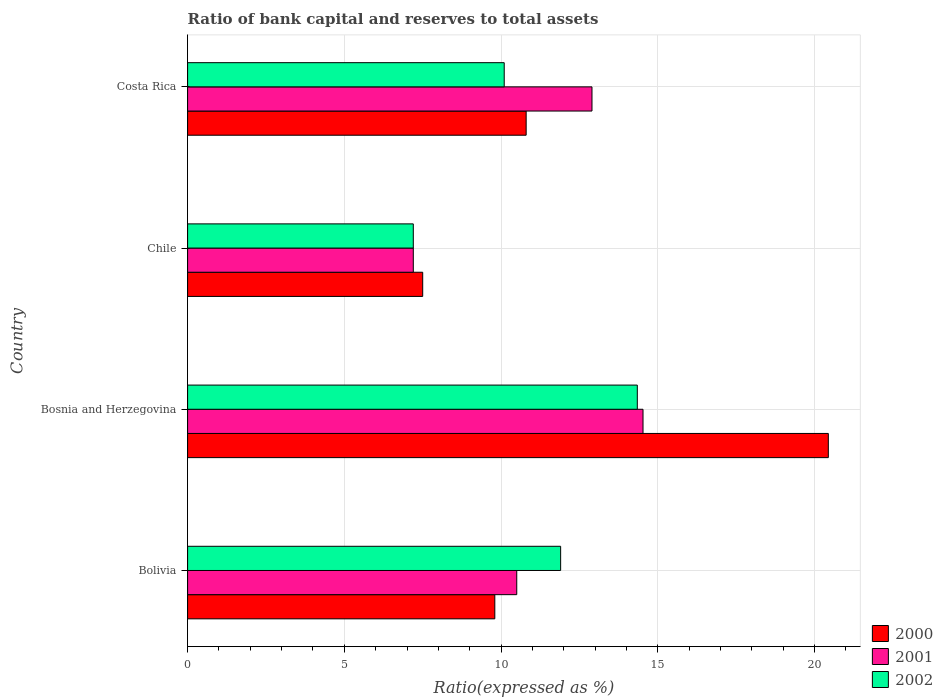How many groups of bars are there?
Offer a very short reply. 4. Are the number of bars on each tick of the Y-axis equal?
Your answer should be very brief. Yes. What is the label of the 2nd group of bars from the top?
Your response must be concise. Chile. What is the ratio of bank capital and reserves to total assets in 2001 in Chile?
Offer a very short reply. 7.2. Across all countries, what is the maximum ratio of bank capital and reserves to total assets in 2002?
Your answer should be compact. 14.35. In which country was the ratio of bank capital and reserves to total assets in 2001 maximum?
Provide a succinct answer. Bosnia and Herzegovina. In which country was the ratio of bank capital and reserves to total assets in 2002 minimum?
Provide a short and direct response. Chile. What is the total ratio of bank capital and reserves to total assets in 2000 in the graph?
Keep it short and to the point. 48.54. What is the difference between the ratio of bank capital and reserves to total assets in 2002 in Bolivia and that in Costa Rica?
Give a very brief answer. 1.8. What is the difference between the ratio of bank capital and reserves to total assets in 2000 in Bolivia and the ratio of bank capital and reserves to total assets in 2002 in Bosnia and Herzegovina?
Make the answer very short. -4.55. What is the average ratio of bank capital and reserves to total assets in 2001 per country?
Give a very brief answer. 11.28. What is the difference between the ratio of bank capital and reserves to total assets in 2001 and ratio of bank capital and reserves to total assets in 2002 in Costa Rica?
Offer a very short reply. 2.8. In how many countries, is the ratio of bank capital and reserves to total assets in 2000 greater than 15 %?
Offer a very short reply. 1. What is the ratio of the ratio of bank capital and reserves to total assets in 2002 in Chile to that in Costa Rica?
Ensure brevity in your answer.  0.71. Is the difference between the ratio of bank capital and reserves to total assets in 2001 in Bolivia and Bosnia and Herzegovina greater than the difference between the ratio of bank capital and reserves to total assets in 2002 in Bolivia and Bosnia and Herzegovina?
Ensure brevity in your answer.  No. What is the difference between the highest and the second highest ratio of bank capital and reserves to total assets in 2000?
Offer a terse response. 9.64. What is the difference between the highest and the lowest ratio of bank capital and reserves to total assets in 2001?
Provide a succinct answer. 7.33. In how many countries, is the ratio of bank capital and reserves to total assets in 2000 greater than the average ratio of bank capital and reserves to total assets in 2000 taken over all countries?
Offer a terse response. 1. Is the sum of the ratio of bank capital and reserves to total assets in 2000 in Chile and Costa Rica greater than the maximum ratio of bank capital and reserves to total assets in 2002 across all countries?
Your answer should be compact. Yes. What does the 3rd bar from the bottom in Costa Rica represents?
Give a very brief answer. 2002. What is the difference between two consecutive major ticks on the X-axis?
Your answer should be very brief. 5. Are the values on the major ticks of X-axis written in scientific E-notation?
Give a very brief answer. No. Does the graph contain any zero values?
Keep it short and to the point. No. How are the legend labels stacked?
Your response must be concise. Vertical. What is the title of the graph?
Make the answer very short. Ratio of bank capital and reserves to total assets. Does "1988" appear as one of the legend labels in the graph?
Your response must be concise. No. What is the label or title of the X-axis?
Provide a succinct answer. Ratio(expressed as %). What is the label or title of the Y-axis?
Provide a succinct answer. Country. What is the Ratio(expressed as %) of 2000 in Bolivia?
Ensure brevity in your answer.  9.8. What is the Ratio(expressed as %) in 2001 in Bolivia?
Provide a succinct answer. 10.5. What is the Ratio(expressed as %) in 2000 in Bosnia and Herzegovina?
Ensure brevity in your answer.  20.44. What is the Ratio(expressed as %) in 2001 in Bosnia and Herzegovina?
Your answer should be compact. 14.53. What is the Ratio(expressed as %) in 2002 in Bosnia and Herzegovina?
Offer a terse response. 14.35. What is the Ratio(expressed as %) of 2000 in Chile?
Ensure brevity in your answer.  7.5. What is the Ratio(expressed as %) in 2001 in Chile?
Your response must be concise. 7.2. What is the Ratio(expressed as %) in 2002 in Chile?
Make the answer very short. 7.2. What is the Ratio(expressed as %) of 2001 in Costa Rica?
Ensure brevity in your answer.  12.9. Across all countries, what is the maximum Ratio(expressed as %) of 2000?
Provide a succinct answer. 20.44. Across all countries, what is the maximum Ratio(expressed as %) in 2001?
Your answer should be very brief. 14.53. Across all countries, what is the maximum Ratio(expressed as %) in 2002?
Offer a terse response. 14.35. Across all countries, what is the minimum Ratio(expressed as %) in 2000?
Offer a very short reply. 7.5. Across all countries, what is the minimum Ratio(expressed as %) of 2001?
Your answer should be compact. 7.2. What is the total Ratio(expressed as %) in 2000 in the graph?
Give a very brief answer. 48.54. What is the total Ratio(expressed as %) in 2001 in the graph?
Your answer should be very brief. 45.13. What is the total Ratio(expressed as %) of 2002 in the graph?
Offer a terse response. 43.55. What is the difference between the Ratio(expressed as %) of 2000 in Bolivia and that in Bosnia and Herzegovina?
Your response must be concise. -10.64. What is the difference between the Ratio(expressed as %) of 2001 in Bolivia and that in Bosnia and Herzegovina?
Offer a terse response. -4.03. What is the difference between the Ratio(expressed as %) of 2002 in Bolivia and that in Bosnia and Herzegovina?
Your answer should be compact. -2.45. What is the difference between the Ratio(expressed as %) in 2000 in Bolivia and that in Chile?
Provide a short and direct response. 2.3. What is the difference between the Ratio(expressed as %) in 2001 in Bolivia and that in Chile?
Offer a very short reply. 3.3. What is the difference between the Ratio(expressed as %) of 2000 in Bolivia and that in Costa Rica?
Give a very brief answer. -1. What is the difference between the Ratio(expressed as %) in 2001 in Bolivia and that in Costa Rica?
Your answer should be compact. -2.4. What is the difference between the Ratio(expressed as %) in 2000 in Bosnia and Herzegovina and that in Chile?
Provide a succinct answer. 12.94. What is the difference between the Ratio(expressed as %) in 2001 in Bosnia and Herzegovina and that in Chile?
Provide a succinct answer. 7.33. What is the difference between the Ratio(expressed as %) in 2002 in Bosnia and Herzegovina and that in Chile?
Your response must be concise. 7.15. What is the difference between the Ratio(expressed as %) in 2000 in Bosnia and Herzegovina and that in Costa Rica?
Your response must be concise. 9.64. What is the difference between the Ratio(expressed as %) of 2001 in Bosnia and Herzegovina and that in Costa Rica?
Your answer should be compact. 1.63. What is the difference between the Ratio(expressed as %) in 2002 in Bosnia and Herzegovina and that in Costa Rica?
Ensure brevity in your answer.  4.25. What is the difference between the Ratio(expressed as %) of 2001 in Chile and that in Costa Rica?
Make the answer very short. -5.7. What is the difference between the Ratio(expressed as %) in 2002 in Chile and that in Costa Rica?
Your response must be concise. -2.9. What is the difference between the Ratio(expressed as %) in 2000 in Bolivia and the Ratio(expressed as %) in 2001 in Bosnia and Herzegovina?
Your answer should be very brief. -4.73. What is the difference between the Ratio(expressed as %) in 2000 in Bolivia and the Ratio(expressed as %) in 2002 in Bosnia and Herzegovina?
Make the answer very short. -4.55. What is the difference between the Ratio(expressed as %) of 2001 in Bolivia and the Ratio(expressed as %) of 2002 in Bosnia and Herzegovina?
Offer a terse response. -3.85. What is the difference between the Ratio(expressed as %) in 2000 in Bolivia and the Ratio(expressed as %) in 2001 in Chile?
Offer a very short reply. 2.6. What is the difference between the Ratio(expressed as %) of 2001 in Bolivia and the Ratio(expressed as %) of 2002 in Chile?
Your answer should be very brief. 3.3. What is the difference between the Ratio(expressed as %) of 2001 in Bolivia and the Ratio(expressed as %) of 2002 in Costa Rica?
Your answer should be very brief. 0.4. What is the difference between the Ratio(expressed as %) of 2000 in Bosnia and Herzegovina and the Ratio(expressed as %) of 2001 in Chile?
Your answer should be compact. 13.24. What is the difference between the Ratio(expressed as %) in 2000 in Bosnia and Herzegovina and the Ratio(expressed as %) in 2002 in Chile?
Give a very brief answer. 13.24. What is the difference between the Ratio(expressed as %) of 2001 in Bosnia and Herzegovina and the Ratio(expressed as %) of 2002 in Chile?
Give a very brief answer. 7.33. What is the difference between the Ratio(expressed as %) of 2000 in Bosnia and Herzegovina and the Ratio(expressed as %) of 2001 in Costa Rica?
Make the answer very short. 7.54. What is the difference between the Ratio(expressed as %) of 2000 in Bosnia and Herzegovina and the Ratio(expressed as %) of 2002 in Costa Rica?
Offer a terse response. 10.34. What is the difference between the Ratio(expressed as %) in 2001 in Bosnia and Herzegovina and the Ratio(expressed as %) in 2002 in Costa Rica?
Offer a terse response. 4.43. What is the difference between the Ratio(expressed as %) in 2000 in Chile and the Ratio(expressed as %) in 2001 in Costa Rica?
Make the answer very short. -5.4. What is the difference between the Ratio(expressed as %) of 2000 in Chile and the Ratio(expressed as %) of 2002 in Costa Rica?
Offer a terse response. -2.6. What is the average Ratio(expressed as %) in 2000 per country?
Make the answer very short. 12.13. What is the average Ratio(expressed as %) in 2001 per country?
Provide a short and direct response. 11.28. What is the average Ratio(expressed as %) in 2002 per country?
Your response must be concise. 10.89. What is the difference between the Ratio(expressed as %) of 2000 and Ratio(expressed as %) of 2001 in Bosnia and Herzegovina?
Your answer should be very brief. 5.91. What is the difference between the Ratio(expressed as %) of 2000 and Ratio(expressed as %) of 2002 in Bosnia and Herzegovina?
Offer a terse response. 6.09. What is the difference between the Ratio(expressed as %) in 2001 and Ratio(expressed as %) in 2002 in Bosnia and Herzegovina?
Keep it short and to the point. 0.18. What is the difference between the Ratio(expressed as %) of 2000 and Ratio(expressed as %) of 2001 in Chile?
Make the answer very short. 0.3. What is the difference between the Ratio(expressed as %) in 2000 and Ratio(expressed as %) in 2002 in Chile?
Offer a very short reply. 0.3. What is the difference between the Ratio(expressed as %) of 2001 and Ratio(expressed as %) of 2002 in Chile?
Offer a very short reply. 0. What is the difference between the Ratio(expressed as %) in 2000 and Ratio(expressed as %) in 2001 in Costa Rica?
Make the answer very short. -2.1. What is the difference between the Ratio(expressed as %) in 2000 and Ratio(expressed as %) in 2002 in Costa Rica?
Your answer should be compact. 0.7. What is the difference between the Ratio(expressed as %) of 2001 and Ratio(expressed as %) of 2002 in Costa Rica?
Provide a succinct answer. 2.8. What is the ratio of the Ratio(expressed as %) in 2000 in Bolivia to that in Bosnia and Herzegovina?
Offer a very short reply. 0.48. What is the ratio of the Ratio(expressed as %) of 2001 in Bolivia to that in Bosnia and Herzegovina?
Keep it short and to the point. 0.72. What is the ratio of the Ratio(expressed as %) in 2002 in Bolivia to that in Bosnia and Herzegovina?
Offer a very short reply. 0.83. What is the ratio of the Ratio(expressed as %) in 2000 in Bolivia to that in Chile?
Give a very brief answer. 1.31. What is the ratio of the Ratio(expressed as %) in 2001 in Bolivia to that in Chile?
Make the answer very short. 1.46. What is the ratio of the Ratio(expressed as %) in 2002 in Bolivia to that in Chile?
Ensure brevity in your answer.  1.65. What is the ratio of the Ratio(expressed as %) of 2000 in Bolivia to that in Costa Rica?
Offer a terse response. 0.91. What is the ratio of the Ratio(expressed as %) in 2001 in Bolivia to that in Costa Rica?
Make the answer very short. 0.81. What is the ratio of the Ratio(expressed as %) in 2002 in Bolivia to that in Costa Rica?
Your response must be concise. 1.18. What is the ratio of the Ratio(expressed as %) of 2000 in Bosnia and Herzegovina to that in Chile?
Offer a terse response. 2.73. What is the ratio of the Ratio(expressed as %) of 2001 in Bosnia and Herzegovina to that in Chile?
Offer a very short reply. 2.02. What is the ratio of the Ratio(expressed as %) in 2002 in Bosnia and Herzegovina to that in Chile?
Offer a terse response. 1.99. What is the ratio of the Ratio(expressed as %) in 2000 in Bosnia and Herzegovina to that in Costa Rica?
Ensure brevity in your answer.  1.89. What is the ratio of the Ratio(expressed as %) in 2001 in Bosnia and Herzegovina to that in Costa Rica?
Your answer should be compact. 1.13. What is the ratio of the Ratio(expressed as %) of 2002 in Bosnia and Herzegovina to that in Costa Rica?
Provide a succinct answer. 1.42. What is the ratio of the Ratio(expressed as %) in 2000 in Chile to that in Costa Rica?
Offer a terse response. 0.69. What is the ratio of the Ratio(expressed as %) in 2001 in Chile to that in Costa Rica?
Ensure brevity in your answer.  0.56. What is the ratio of the Ratio(expressed as %) in 2002 in Chile to that in Costa Rica?
Offer a very short reply. 0.71. What is the difference between the highest and the second highest Ratio(expressed as %) in 2000?
Your response must be concise. 9.64. What is the difference between the highest and the second highest Ratio(expressed as %) in 2001?
Your response must be concise. 1.63. What is the difference between the highest and the second highest Ratio(expressed as %) of 2002?
Provide a short and direct response. 2.45. What is the difference between the highest and the lowest Ratio(expressed as %) of 2000?
Your response must be concise. 12.94. What is the difference between the highest and the lowest Ratio(expressed as %) of 2001?
Your answer should be very brief. 7.33. What is the difference between the highest and the lowest Ratio(expressed as %) of 2002?
Provide a succinct answer. 7.15. 